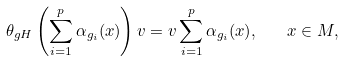Convert formula to latex. <formula><loc_0><loc_0><loc_500><loc_500>\theta _ { g H } \left ( \sum ^ { p } _ { i = 1 } \alpha _ { g _ { i } } ( x ) \right ) v = v \sum ^ { p } _ { i = 1 } \alpha _ { g _ { i } } ( x ) , \quad x \in M ,</formula> 